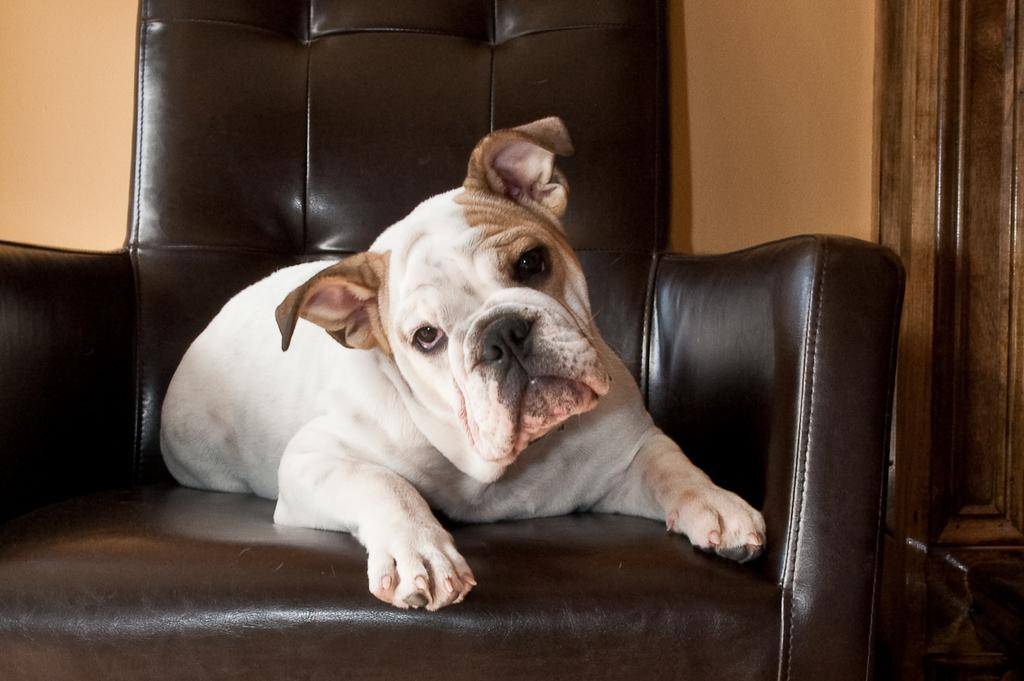What type of animal is in the image? There is a dog in the image. Where is the dog located? The dog is sitting on a sofa chair. What type of crow is sitting on the linen in the image? There is no crow or linen present in the image; it features a dog sitting on a sofa chair. 